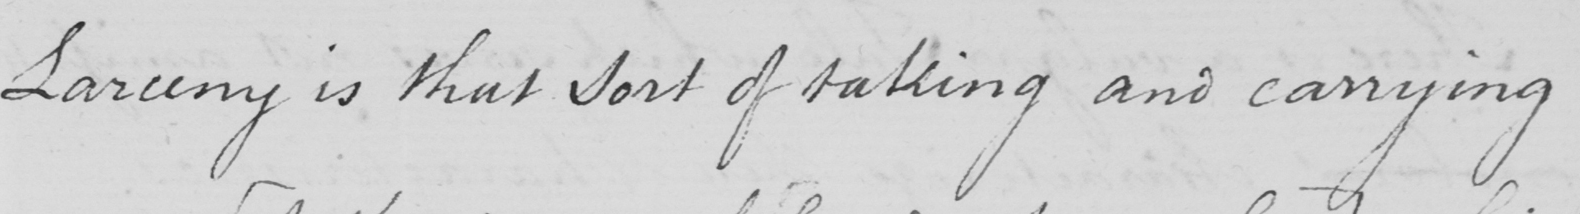What does this handwritten line say? Larceny is that sort of taking and carrying 